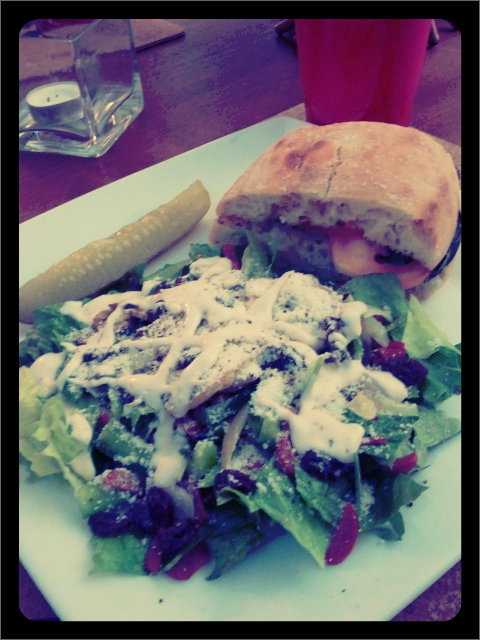Describe the objects in this image and their specific colors. I can see sandwich in dimgray, tan, gray, and navy tones, dining table in dimgray, purple, navy, and black tones, cup in dimgray, purple, darkgray, and navy tones, cup in dimgray, purple, and navy tones, and broccoli in dimgray, teal, and navy tones in this image. 